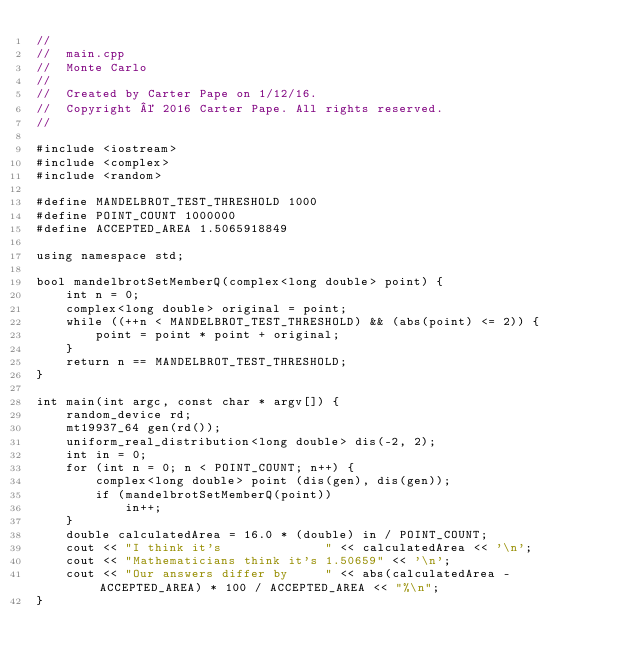Convert code to text. <code><loc_0><loc_0><loc_500><loc_500><_C++_>//
//  main.cpp
//  Monte Carlo
//
//  Created by Carter Pape on 1/12/16.
//  Copyright © 2016 Carter Pape. All rights reserved.
//

#include <iostream>
#include <complex>
#include <random>

#define MANDELBROT_TEST_THRESHOLD 1000
#define POINT_COUNT 1000000
#define ACCEPTED_AREA 1.5065918849

using namespace std;

bool mandelbrotSetMemberQ(complex<long double> point) {
    int n = 0;
    complex<long double> original = point;
    while ((++n < MANDELBROT_TEST_THRESHOLD) && (abs(point) <= 2)) {
        point = point * point + original;
    }
    return n == MANDELBROT_TEST_THRESHOLD;
}

int main(int argc, const char * argv[]) {
    random_device rd;
    mt19937_64 gen(rd());
    uniform_real_distribution<long double> dis(-2, 2);
    int in = 0;
    for (int n = 0; n < POINT_COUNT; n++) {
        complex<long double> point (dis(gen), dis(gen));
        if (mandelbrotSetMemberQ(point))
            in++;
    }
    double calculatedArea = 16.0 * (double) in / POINT_COUNT;
    cout << "I think it's              " << calculatedArea << '\n';
    cout << "Mathematicians think it's 1.50659" << '\n';
    cout << "Our answers differ by     " << abs(calculatedArea - ACCEPTED_AREA) * 100 / ACCEPTED_AREA << "%\n";
}
</code> 